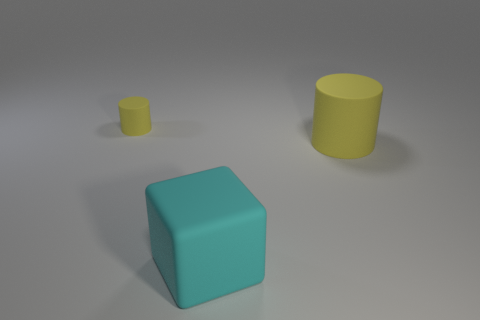There is a tiny cylinder; is it the same color as the cylinder that is right of the tiny yellow matte cylinder?
Offer a terse response. Yes. There is a cyan matte block; how many big rubber cylinders are right of it?
Offer a very short reply. 1. Is there another cylinder of the same color as the big rubber cylinder?
Keep it short and to the point. Yes. There is a yellow thing that is the same size as the cyan object; what is its shape?
Offer a very short reply. Cylinder. How many gray things are either big rubber cubes or big cylinders?
Provide a succinct answer. 0. What number of matte blocks are the same size as the cyan rubber thing?
Give a very brief answer. 0. There is another rubber object that is the same color as the small rubber thing; what is its shape?
Give a very brief answer. Cylinder. How many objects are tiny brown objects or yellow rubber objects that are in front of the tiny object?
Your answer should be very brief. 1. There is a rubber cylinder on the right side of the large block; does it have the same size as the cyan matte cube that is in front of the tiny yellow matte object?
Provide a succinct answer. Yes. What number of small yellow matte things have the same shape as the large yellow object?
Give a very brief answer. 1. 